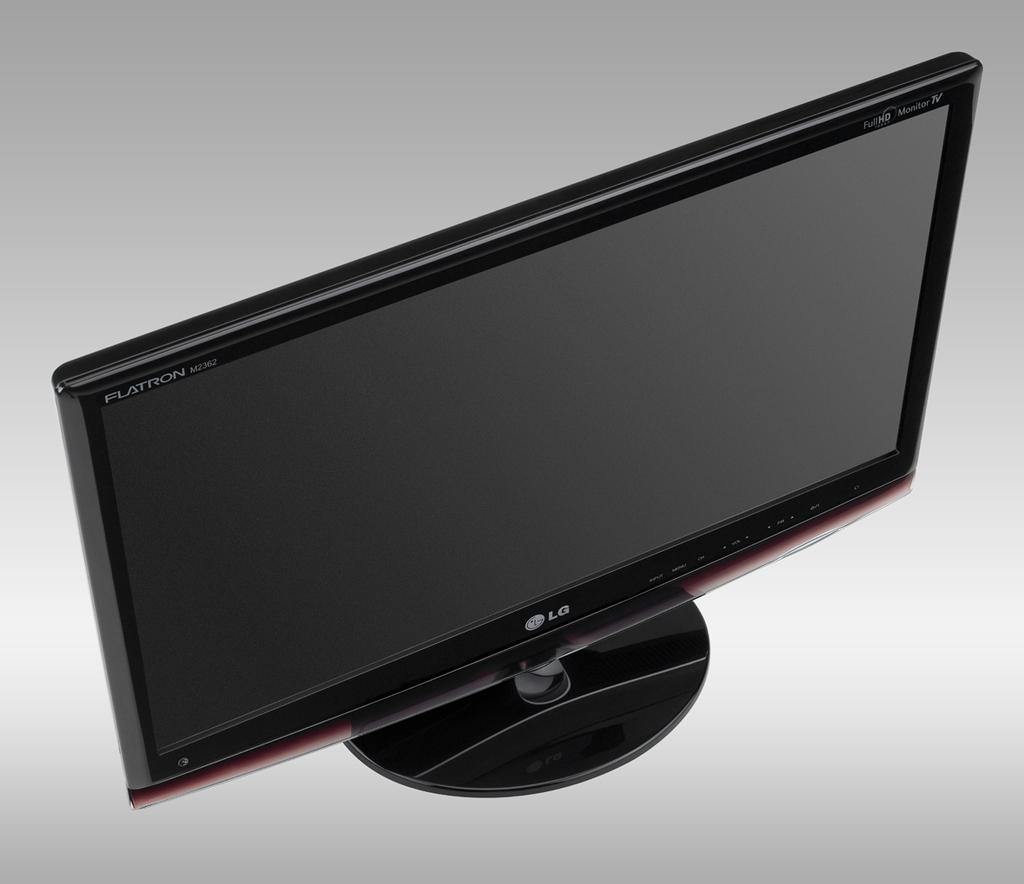<image>
Present a compact description of the photo's key features. An unpowered LG branded computer monitor with the stand attached to it. 